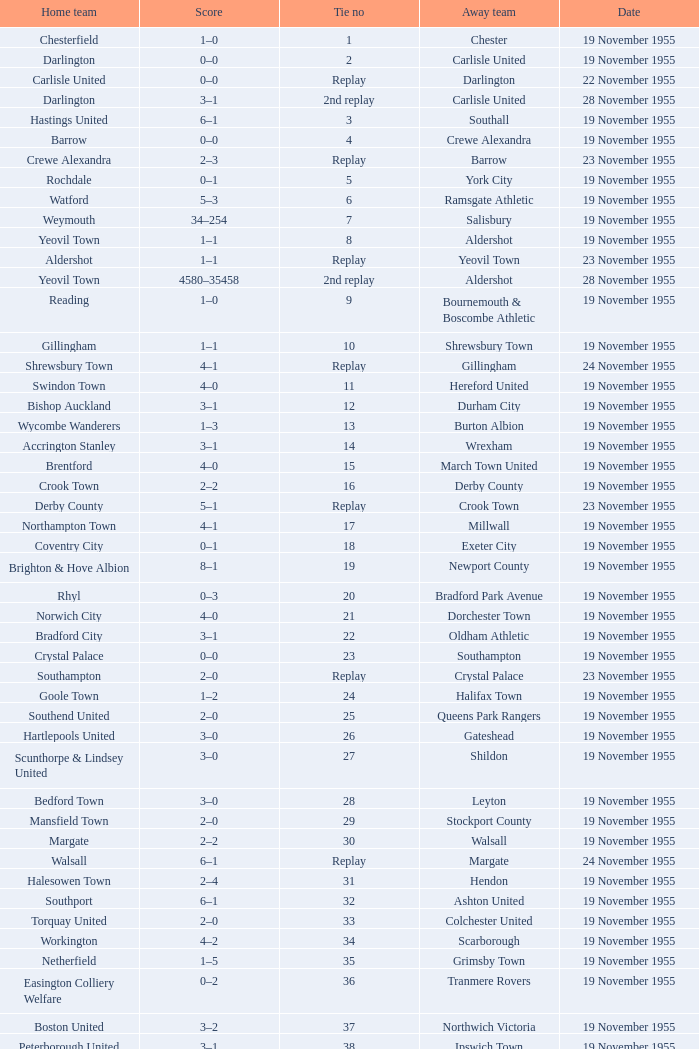Parse the full table. {'header': ['Home team', 'Score', 'Tie no', 'Away team', 'Date'], 'rows': [['Chesterfield', '1–0', '1', 'Chester', '19 November 1955'], ['Darlington', '0–0', '2', 'Carlisle United', '19 November 1955'], ['Carlisle United', '0–0', 'Replay', 'Darlington', '22 November 1955'], ['Darlington', '3–1', '2nd replay', 'Carlisle United', '28 November 1955'], ['Hastings United', '6–1', '3', 'Southall', '19 November 1955'], ['Barrow', '0–0', '4', 'Crewe Alexandra', '19 November 1955'], ['Crewe Alexandra', '2–3', 'Replay', 'Barrow', '23 November 1955'], ['Rochdale', '0–1', '5', 'York City', '19 November 1955'], ['Watford', '5–3', '6', 'Ramsgate Athletic', '19 November 1955'], ['Weymouth', '34–254', '7', 'Salisbury', '19 November 1955'], ['Yeovil Town', '1–1', '8', 'Aldershot', '19 November 1955'], ['Aldershot', '1–1', 'Replay', 'Yeovil Town', '23 November 1955'], ['Yeovil Town', '4580–35458', '2nd replay', 'Aldershot', '28 November 1955'], ['Reading', '1–0', '9', 'Bournemouth & Boscombe Athletic', '19 November 1955'], ['Gillingham', '1–1', '10', 'Shrewsbury Town', '19 November 1955'], ['Shrewsbury Town', '4–1', 'Replay', 'Gillingham', '24 November 1955'], ['Swindon Town', '4–0', '11', 'Hereford United', '19 November 1955'], ['Bishop Auckland', '3–1', '12', 'Durham City', '19 November 1955'], ['Wycombe Wanderers', '1–3', '13', 'Burton Albion', '19 November 1955'], ['Accrington Stanley', '3–1', '14', 'Wrexham', '19 November 1955'], ['Brentford', '4–0', '15', 'March Town United', '19 November 1955'], ['Crook Town', '2–2', '16', 'Derby County', '19 November 1955'], ['Derby County', '5–1', 'Replay', 'Crook Town', '23 November 1955'], ['Northampton Town', '4–1', '17', 'Millwall', '19 November 1955'], ['Coventry City', '0–1', '18', 'Exeter City', '19 November 1955'], ['Brighton & Hove Albion', '8–1', '19', 'Newport County', '19 November 1955'], ['Rhyl', '0–3', '20', 'Bradford Park Avenue', '19 November 1955'], ['Norwich City', '4–0', '21', 'Dorchester Town', '19 November 1955'], ['Bradford City', '3–1', '22', 'Oldham Athletic', '19 November 1955'], ['Crystal Palace', '0–0', '23', 'Southampton', '19 November 1955'], ['Southampton', '2–0', 'Replay', 'Crystal Palace', '23 November 1955'], ['Goole Town', '1–2', '24', 'Halifax Town', '19 November 1955'], ['Southend United', '2–0', '25', 'Queens Park Rangers', '19 November 1955'], ['Hartlepools United', '3–0', '26', 'Gateshead', '19 November 1955'], ['Scunthorpe & Lindsey United', '3–0', '27', 'Shildon', '19 November 1955'], ['Bedford Town', '3–0', '28', 'Leyton', '19 November 1955'], ['Mansfield Town', '2–0', '29', 'Stockport County', '19 November 1955'], ['Margate', '2–2', '30', 'Walsall', '19 November 1955'], ['Walsall', '6–1', 'Replay', 'Margate', '24 November 1955'], ['Halesowen Town', '2–4', '31', 'Hendon', '19 November 1955'], ['Southport', '6–1', '32', 'Ashton United', '19 November 1955'], ['Torquay United', '2–0', '33', 'Colchester United', '19 November 1955'], ['Workington', '4–2', '34', 'Scarborough', '19 November 1955'], ['Netherfield', '1–5', '35', 'Grimsby Town', '19 November 1955'], ['Easington Colliery Welfare', '0–2', '36', 'Tranmere Rovers', '19 November 1955'], ['Boston United', '3–2', '37', 'Northwich Victoria', '19 November 1955'], ['Peterborough United', '3–1', '38', 'Ipswich Town', '19 November 1955'], ['Leyton Orient', '7–1', '39', 'Lovells Athletic', '19 November 1955'], ['Skegness Town', '0–4', '40', 'Worksop Town', '19 November 1955']]} What is the date of tie no. 34? 19 November 1955. 